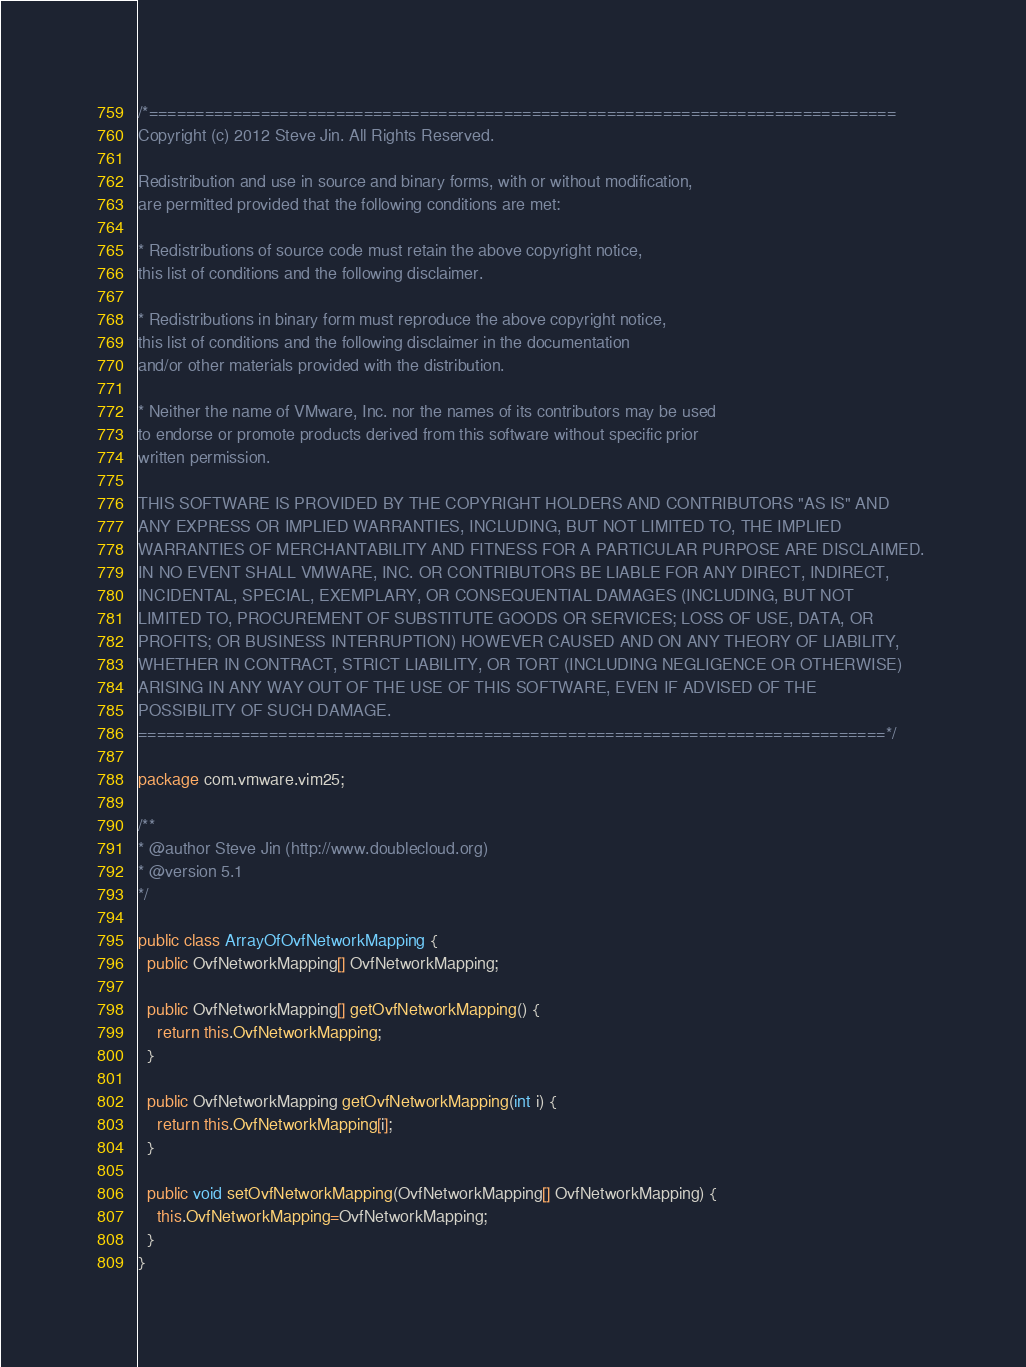<code> <loc_0><loc_0><loc_500><loc_500><_Java_>/*================================================================================
Copyright (c) 2012 Steve Jin. All Rights Reserved.

Redistribution and use in source and binary forms, with or without modification, 
are permitted provided that the following conditions are met:

* Redistributions of source code must retain the above copyright notice, 
this list of conditions and the following disclaimer.

* Redistributions in binary form must reproduce the above copyright notice, 
this list of conditions and the following disclaimer in the documentation 
and/or other materials provided with the distribution.

* Neither the name of VMware, Inc. nor the names of its contributors may be used
to endorse or promote products derived from this software without specific prior 
written permission.

THIS SOFTWARE IS PROVIDED BY THE COPYRIGHT HOLDERS AND CONTRIBUTORS "AS IS" AND 
ANY EXPRESS OR IMPLIED WARRANTIES, INCLUDING, BUT NOT LIMITED TO, THE IMPLIED 
WARRANTIES OF MERCHANTABILITY AND FITNESS FOR A PARTICULAR PURPOSE ARE DISCLAIMED. 
IN NO EVENT SHALL VMWARE, INC. OR CONTRIBUTORS BE LIABLE FOR ANY DIRECT, INDIRECT, 
INCIDENTAL, SPECIAL, EXEMPLARY, OR CONSEQUENTIAL DAMAGES (INCLUDING, BUT NOT 
LIMITED TO, PROCUREMENT OF SUBSTITUTE GOODS OR SERVICES; LOSS OF USE, DATA, OR 
PROFITS; OR BUSINESS INTERRUPTION) HOWEVER CAUSED AND ON ANY THEORY OF LIABILITY, 
WHETHER IN CONTRACT, STRICT LIABILITY, OR TORT (INCLUDING NEGLIGENCE OR OTHERWISE) 
ARISING IN ANY WAY OUT OF THE USE OF THIS SOFTWARE, EVEN IF ADVISED OF THE 
POSSIBILITY OF SUCH DAMAGE.
================================================================================*/

package com.vmware.vim25;

/**
* @author Steve Jin (http://www.doublecloud.org)
* @version 5.1
*/

public class ArrayOfOvfNetworkMapping {
  public OvfNetworkMapping[] OvfNetworkMapping;

  public OvfNetworkMapping[] getOvfNetworkMapping() {
    return this.OvfNetworkMapping;
  }

  public OvfNetworkMapping getOvfNetworkMapping(int i) {
    return this.OvfNetworkMapping[i];
  }

  public void setOvfNetworkMapping(OvfNetworkMapping[] OvfNetworkMapping) {
    this.OvfNetworkMapping=OvfNetworkMapping;
  }
}</code> 